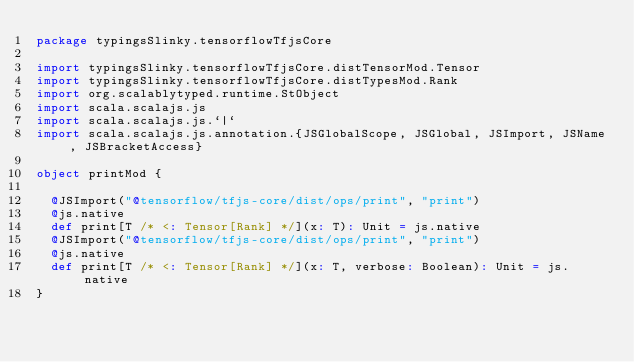Convert code to text. <code><loc_0><loc_0><loc_500><loc_500><_Scala_>package typingsSlinky.tensorflowTfjsCore

import typingsSlinky.tensorflowTfjsCore.distTensorMod.Tensor
import typingsSlinky.tensorflowTfjsCore.distTypesMod.Rank
import org.scalablytyped.runtime.StObject
import scala.scalajs.js
import scala.scalajs.js.`|`
import scala.scalajs.js.annotation.{JSGlobalScope, JSGlobal, JSImport, JSName, JSBracketAccess}

object printMod {
  
  @JSImport("@tensorflow/tfjs-core/dist/ops/print", "print")
  @js.native
  def print[T /* <: Tensor[Rank] */](x: T): Unit = js.native
  @JSImport("@tensorflow/tfjs-core/dist/ops/print", "print")
  @js.native
  def print[T /* <: Tensor[Rank] */](x: T, verbose: Boolean): Unit = js.native
}
</code> 